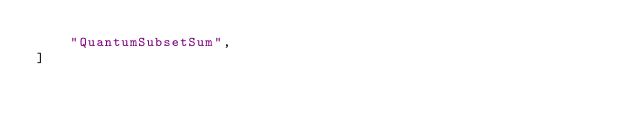<code> <loc_0><loc_0><loc_500><loc_500><_Python_>    "QuantumSubsetSum",
]
</code> 